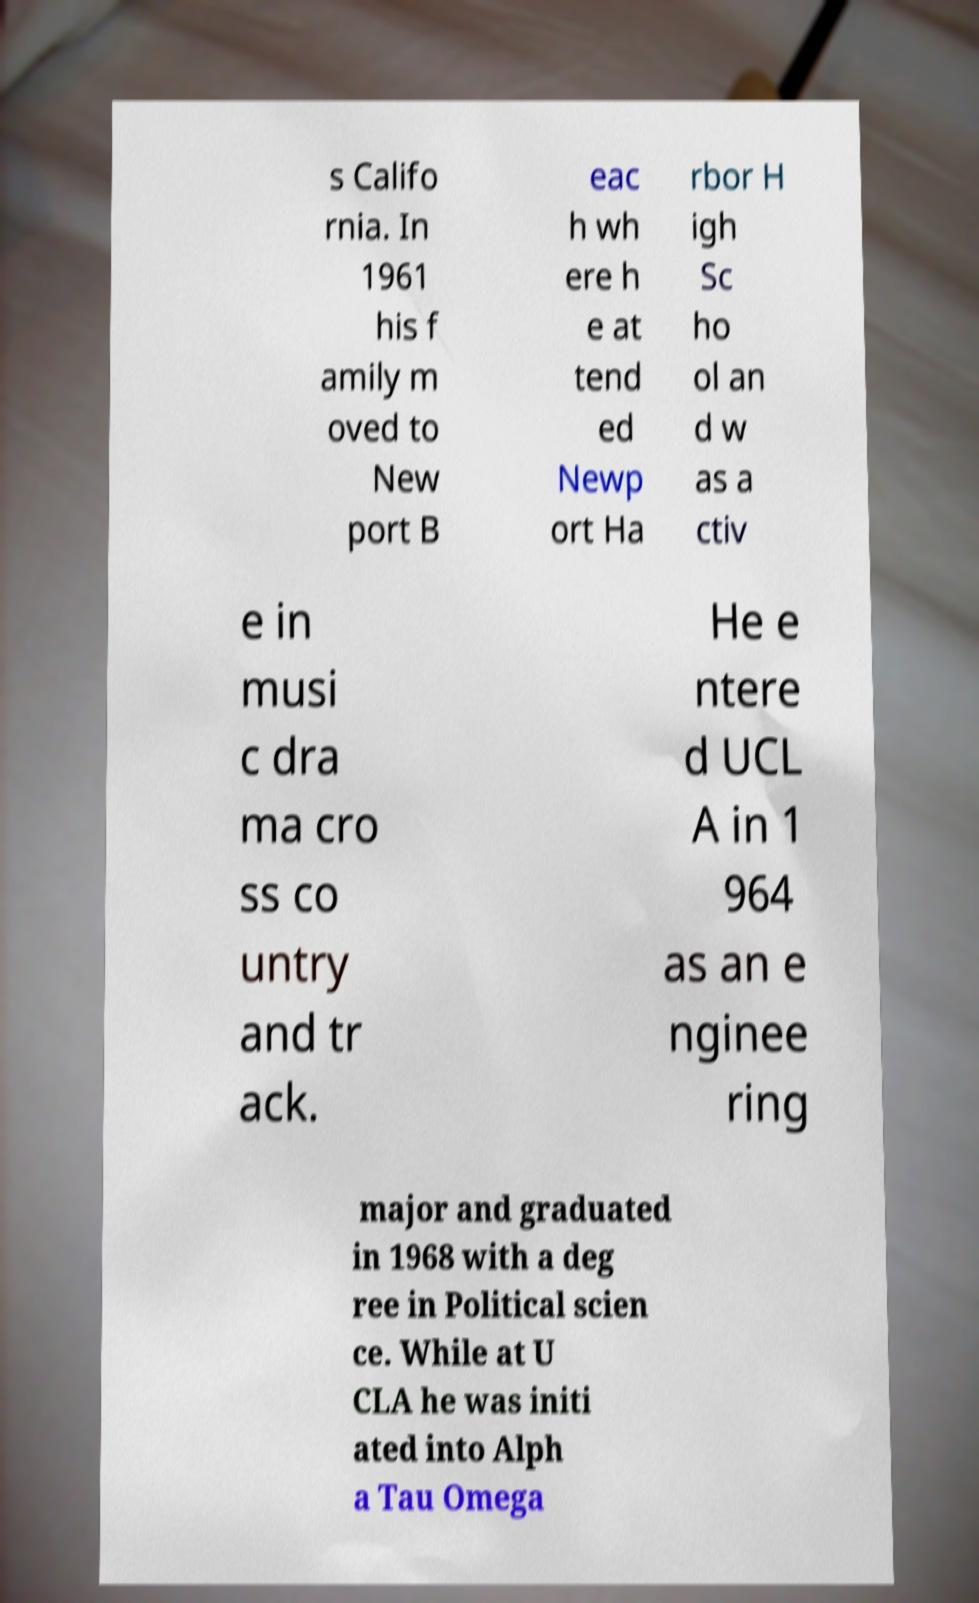Please identify and transcribe the text found in this image. s Califo rnia. In 1961 his f amily m oved to New port B eac h wh ere h e at tend ed Newp ort Ha rbor H igh Sc ho ol an d w as a ctiv e in musi c dra ma cro ss co untry and tr ack. He e ntere d UCL A in 1 964 as an e nginee ring major and graduated in 1968 with a deg ree in Political scien ce. While at U CLA he was initi ated into Alph a Tau Omega 